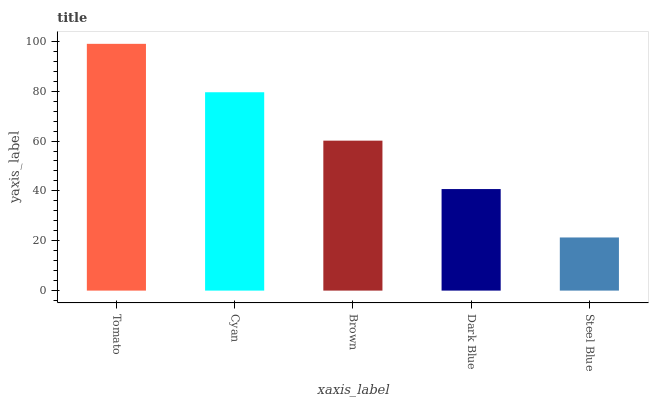Is Steel Blue the minimum?
Answer yes or no. Yes. Is Tomato the maximum?
Answer yes or no. Yes. Is Cyan the minimum?
Answer yes or no. No. Is Cyan the maximum?
Answer yes or no. No. Is Tomato greater than Cyan?
Answer yes or no. Yes. Is Cyan less than Tomato?
Answer yes or no. Yes. Is Cyan greater than Tomato?
Answer yes or no. No. Is Tomato less than Cyan?
Answer yes or no. No. Is Brown the high median?
Answer yes or no. Yes. Is Brown the low median?
Answer yes or no. Yes. Is Tomato the high median?
Answer yes or no. No. Is Tomato the low median?
Answer yes or no. No. 